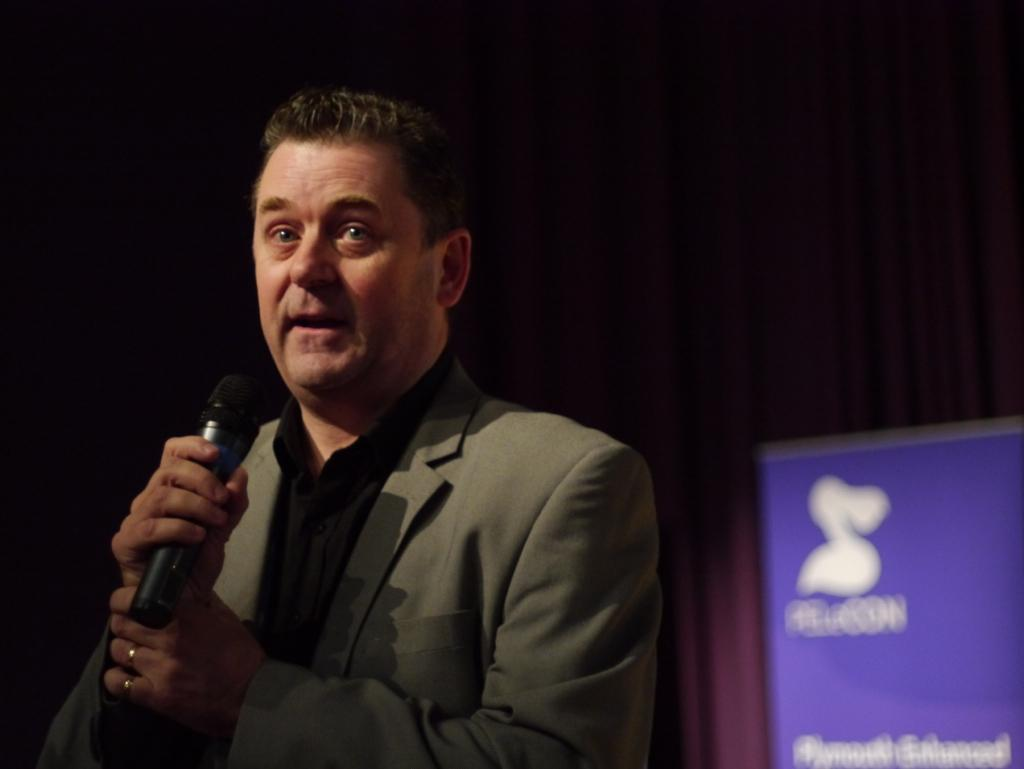Who is present in the image? There is a man in the image. What is the man doing in the image? The man is standing and talking using a microphone. What can be seen in the background of the image? There is a hoarding in the background of the image. What type of yarn is the man using to communicate in the image? The man is not using yarn to communicate in the image; he is using a microphone. What memory is the man trying to recall while talking in the image? There is no indication in the image that the man is trying to recall a memory while talking. 